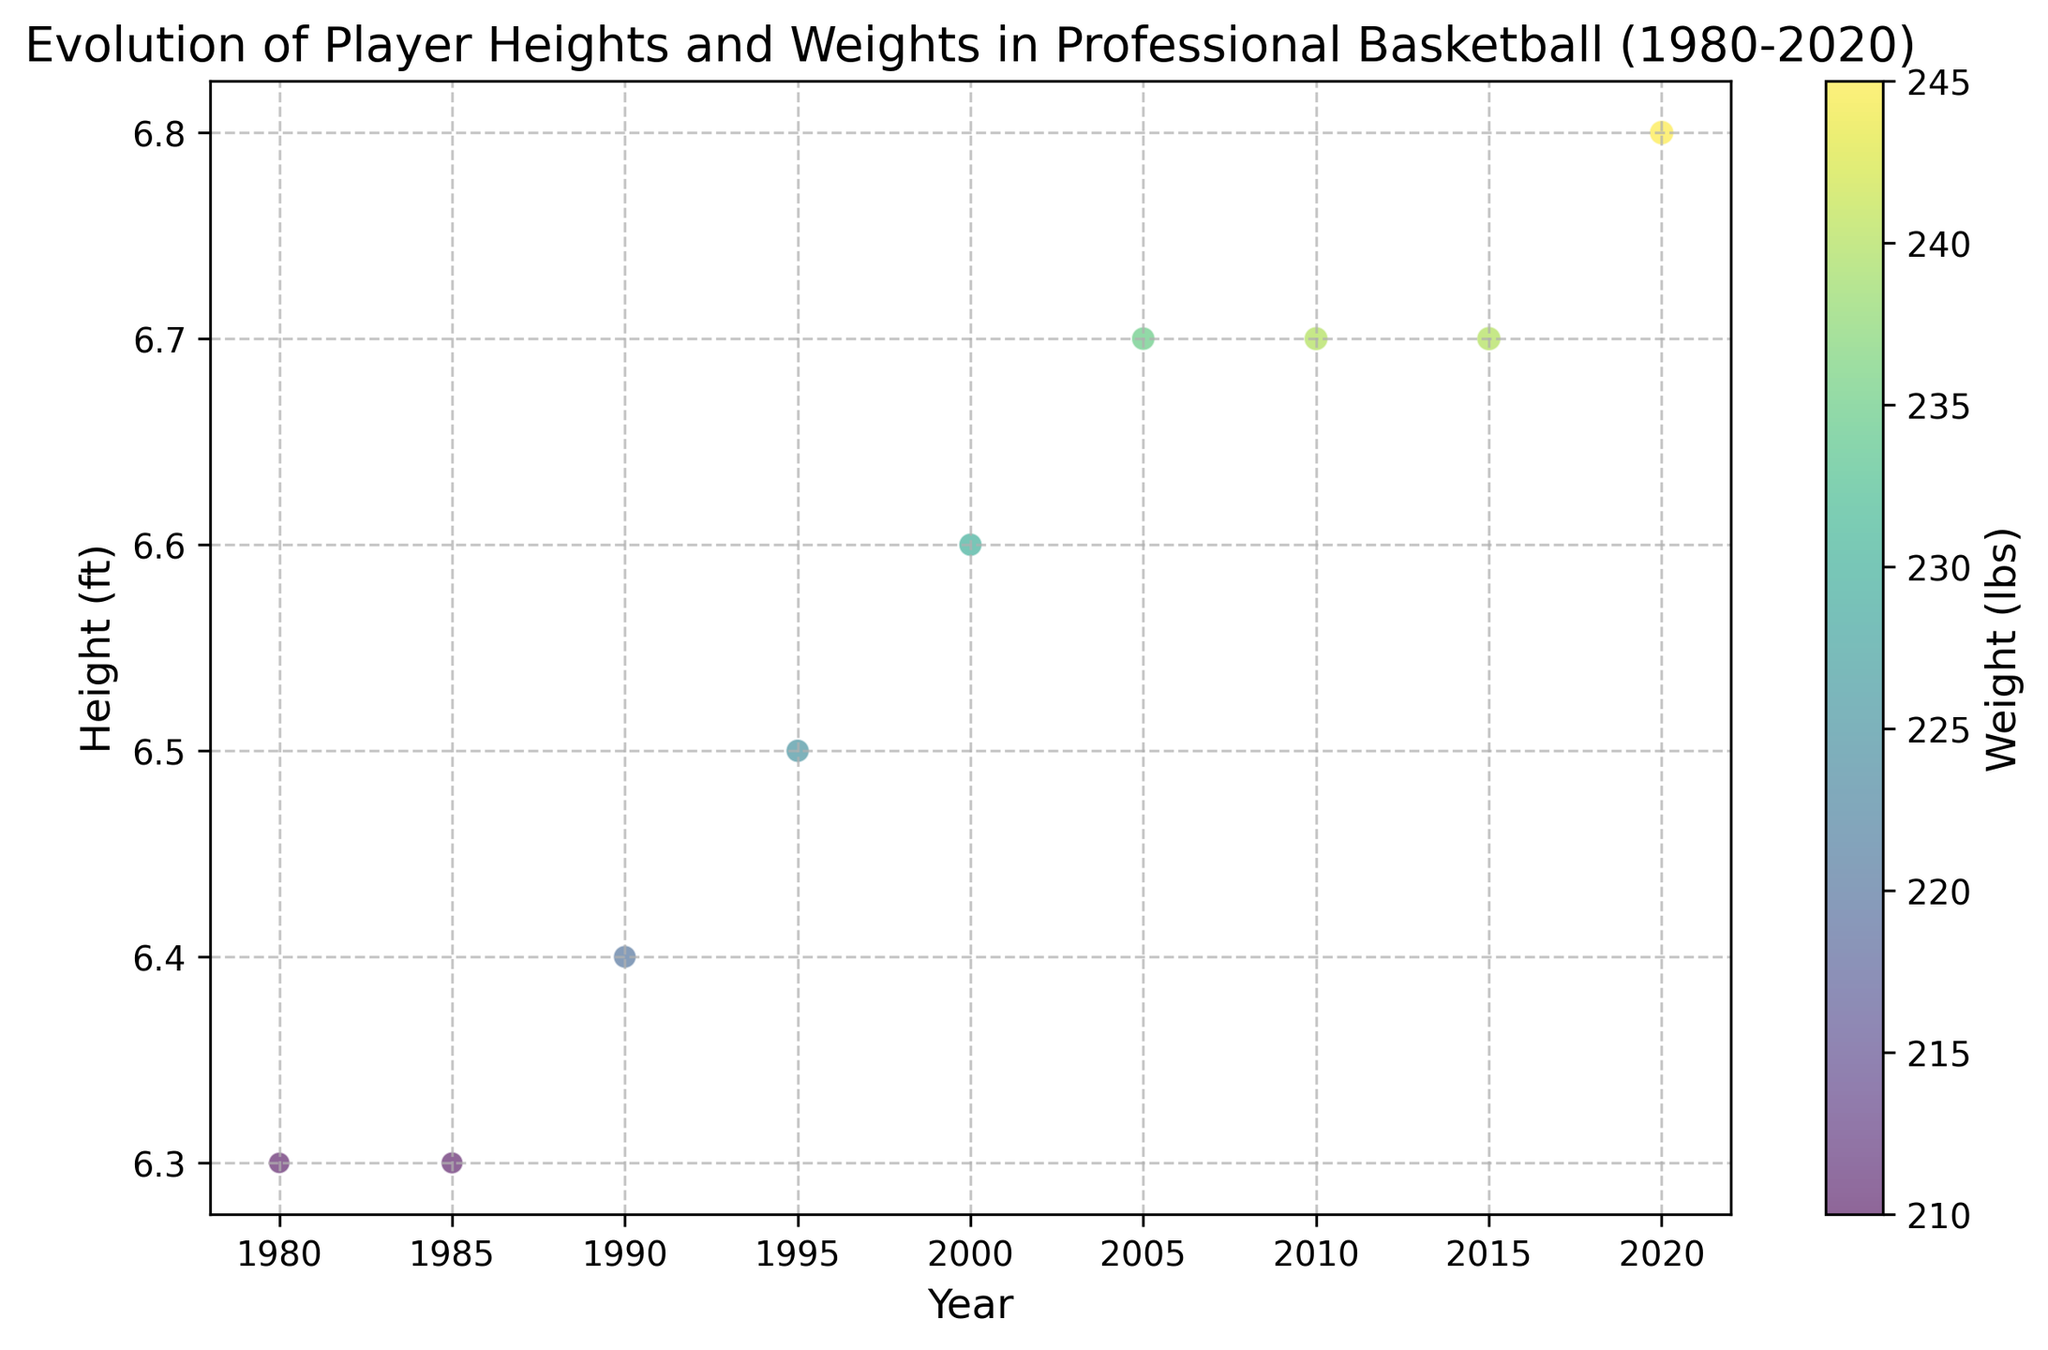What is the average player height in 1980 and 2020? To get the average player height, sum the heights for each year and divide by two. The heights for 1980 and 2020 are 6.3 ft and 6.8 ft, respectively. (6.3 + 6.8) / 2 = 6.55 ft.
Answer: 6.55 ft How did the number of players change from 1980 to 2020? The number of players in 1980 was 400 and in 2020 was 520. To find the change, subtract the number in 1980 from the number in 2020. 520 - 400 = 120.
Answer: Increased by 120 Which year had the tallest average player height? By inspecting the vertical positions of the bubbles, 2020 shows the tallest average player height of 6.8 ft.
Answer: 2020 In which year did the average weight of players reach 240 lbs? By inspecting the color gradient, the average player weight is indicated by the color bar. The 240 lbs color appears for both 2010 and 2015.
Answer: 2010 and 2015 By how much did average player height increase from 1985 to 2000? The average heights were 6.3 ft in 1985 and 6.6 ft in 2000. Subtract the height in 1985 from the height in 2000. 6.6 - 6.3 = 0.3 ft.
Answer: 0.3 ft Compare the number of players in 2005 and 2015. Which year had more? The number of players in 2005 was 480, and in 2015 it was 510. Since 510 > 480, 2015 had more players.
Answer: 2015 had more players Which year shows the largest increase in player weight from the previous year? Visual inspection of the color gradient indicates the most noticeable change between consecutive years occurred between 1985 (210 lbs) and 1990 (220 lbs), showing a 10 lbs increase.
Answer: 1990 In what year was the average player height first recorded at 6.7 ft? By inspecting the height positions, 2005 is the first year where the average player height reaches 6.7 ft.
Answer: 2005 What is the difference in average player weight between 1990 and 2020? In 1990, the average weight was 220 lbs, and in 2020 it was 245 lbs. Subtract the weight in 1990 from the weight in 2020. 245 - 220 = 25 lbs.
Answer: 25 lbs Considering all years, what is the overall trend in player height and weight? By observing the increasing height and color gradient from light to dark, there is an upward trend in both height and weight from 1980 to 2020.
Answer: Upward trend 